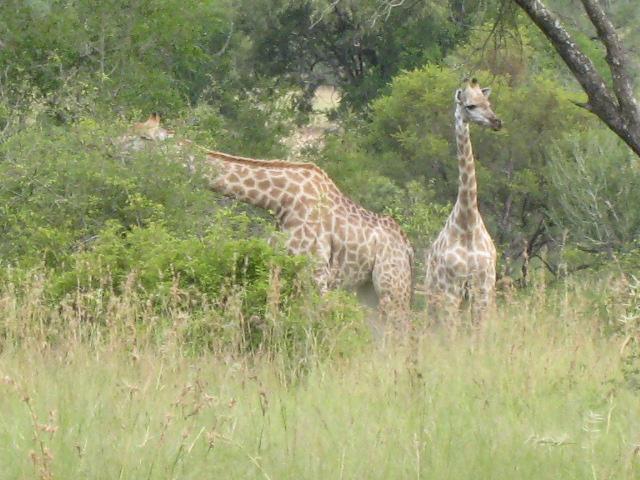How might you assume these two are related?
Quick response, please. Siblings. Where are the giraffes?
Concise answer only. Wild. Is the animal eating?
Short answer required. Yes. How many giraffes are there?
Be succinct. 2. Are these animals in the wild?
Write a very short answer. Yes. Is the giraffe eating?
Write a very short answer. Yes. How many giraffes are looking toward the camera?
Keep it brief. 1. 